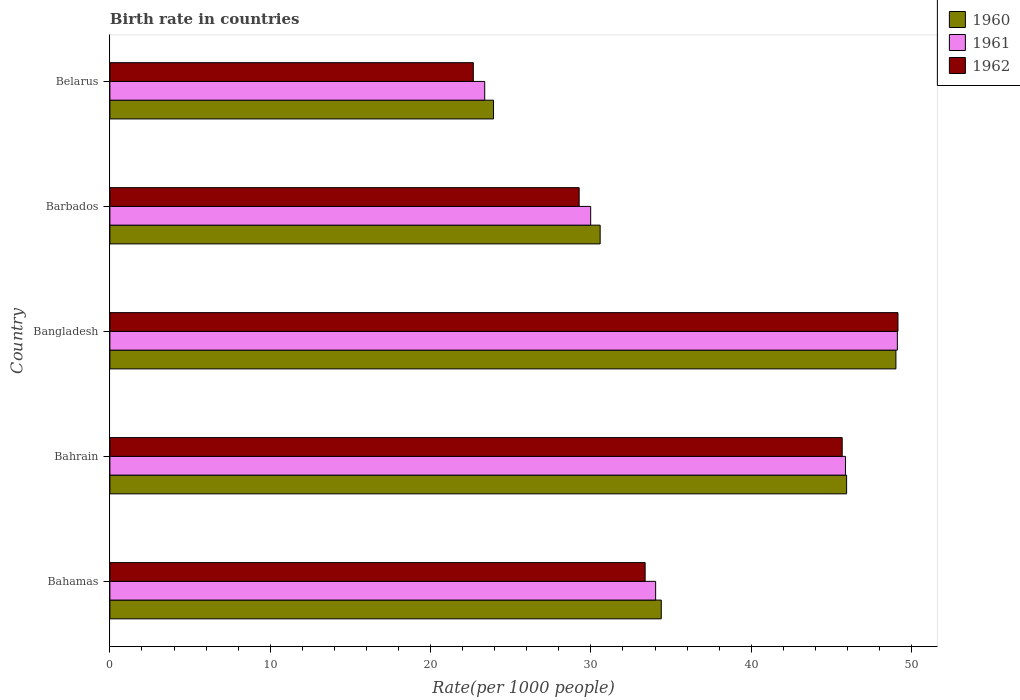How many bars are there on the 3rd tick from the top?
Your response must be concise. 3. How many bars are there on the 2nd tick from the bottom?
Give a very brief answer. 3. What is the label of the 1st group of bars from the top?
Your response must be concise. Belarus. In how many cases, is the number of bars for a given country not equal to the number of legend labels?
Keep it short and to the point. 0. What is the birth rate in 1961 in Barbados?
Give a very brief answer. 29.98. Across all countries, what is the maximum birth rate in 1962?
Your answer should be very brief. 49.15. Across all countries, what is the minimum birth rate in 1960?
Offer a very short reply. 23.93. In which country was the birth rate in 1962 minimum?
Offer a very short reply. Belarus. What is the total birth rate in 1961 in the graph?
Your answer should be very brief. 182.38. What is the difference between the birth rate in 1962 in Bangladesh and that in Belarus?
Your answer should be very brief. 26.48. What is the difference between the birth rate in 1960 in Barbados and the birth rate in 1961 in Belarus?
Ensure brevity in your answer.  7.2. What is the average birth rate in 1960 per country?
Ensure brevity in your answer.  36.77. What is the difference between the birth rate in 1961 and birth rate in 1962 in Belarus?
Provide a succinct answer. 0.71. What is the ratio of the birth rate in 1960 in Bahamas to that in Bangladesh?
Offer a terse response. 0.7. What is the difference between the highest and the second highest birth rate in 1962?
Provide a short and direct response. 3.48. What is the difference between the highest and the lowest birth rate in 1962?
Your answer should be very brief. 26.48. In how many countries, is the birth rate in 1960 greater than the average birth rate in 1960 taken over all countries?
Provide a short and direct response. 2. Is the sum of the birth rate in 1961 in Bangladesh and Belarus greater than the maximum birth rate in 1962 across all countries?
Keep it short and to the point. Yes. What does the 1st bar from the bottom in Bahamas represents?
Give a very brief answer. 1960. Is it the case that in every country, the sum of the birth rate in 1960 and birth rate in 1961 is greater than the birth rate in 1962?
Keep it short and to the point. Yes. How many countries are there in the graph?
Make the answer very short. 5. Are the values on the major ticks of X-axis written in scientific E-notation?
Ensure brevity in your answer.  No. How many legend labels are there?
Offer a terse response. 3. What is the title of the graph?
Your response must be concise. Birth rate in countries. Does "2015" appear as one of the legend labels in the graph?
Your answer should be compact. No. What is the label or title of the X-axis?
Give a very brief answer. Rate(per 1000 people). What is the label or title of the Y-axis?
Offer a terse response. Country. What is the Rate(per 1000 people) of 1960 in Bahamas?
Make the answer very short. 34.39. What is the Rate(per 1000 people) in 1961 in Bahamas?
Your response must be concise. 34.04. What is the Rate(per 1000 people) in 1962 in Bahamas?
Offer a very short reply. 33.38. What is the Rate(per 1000 people) in 1960 in Bahrain?
Offer a very short reply. 45.95. What is the Rate(per 1000 people) of 1961 in Bahrain?
Make the answer very short. 45.88. What is the Rate(per 1000 people) of 1962 in Bahrain?
Your answer should be compact. 45.67. What is the Rate(per 1000 people) in 1960 in Bangladesh?
Offer a very short reply. 49.02. What is the Rate(per 1000 people) of 1961 in Bangladesh?
Ensure brevity in your answer.  49.11. What is the Rate(per 1000 people) of 1962 in Bangladesh?
Your answer should be very brief. 49.15. What is the Rate(per 1000 people) in 1960 in Barbados?
Ensure brevity in your answer.  30.58. What is the Rate(per 1000 people) in 1961 in Barbados?
Provide a succinct answer. 29.98. What is the Rate(per 1000 people) in 1962 in Barbados?
Provide a short and direct response. 29.27. What is the Rate(per 1000 people) of 1960 in Belarus?
Ensure brevity in your answer.  23.93. What is the Rate(per 1000 people) of 1961 in Belarus?
Keep it short and to the point. 23.38. What is the Rate(per 1000 people) in 1962 in Belarus?
Provide a short and direct response. 22.66. Across all countries, what is the maximum Rate(per 1000 people) in 1960?
Make the answer very short. 49.02. Across all countries, what is the maximum Rate(per 1000 people) of 1961?
Provide a succinct answer. 49.11. Across all countries, what is the maximum Rate(per 1000 people) of 1962?
Ensure brevity in your answer.  49.15. Across all countries, what is the minimum Rate(per 1000 people) in 1960?
Provide a succinct answer. 23.93. Across all countries, what is the minimum Rate(per 1000 people) in 1961?
Give a very brief answer. 23.38. Across all countries, what is the minimum Rate(per 1000 people) in 1962?
Your response must be concise. 22.66. What is the total Rate(per 1000 people) of 1960 in the graph?
Your answer should be compact. 183.86. What is the total Rate(per 1000 people) in 1961 in the graph?
Your answer should be very brief. 182.38. What is the total Rate(per 1000 people) of 1962 in the graph?
Make the answer very short. 180.13. What is the difference between the Rate(per 1000 people) in 1960 in Bahamas and that in Bahrain?
Provide a succinct answer. -11.56. What is the difference between the Rate(per 1000 people) of 1961 in Bahamas and that in Bahrain?
Ensure brevity in your answer.  -11.84. What is the difference between the Rate(per 1000 people) of 1962 in Bahamas and that in Bahrain?
Your answer should be very brief. -12.29. What is the difference between the Rate(per 1000 people) of 1960 in Bahamas and that in Bangladesh?
Your answer should be very brief. -14.63. What is the difference between the Rate(per 1000 people) of 1961 in Bahamas and that in Bangladesh?
Keep it short and to the point. -15.07. What is the difference between the Rate(per 1000 people) in 1962 in Bahamas and that in Bangladesh?
Ensure brevity in your answer.  -15.77. What is the difference between the Rate(per 1000 people) of 1960 in Bahamas and that in Barbados?
Ensure brevity in your answer.  3.81. What is the difference between the Rate(per 1000 people) in 1961 in Bahamas and that in Barbados?
Ensure brevity in your answer.  4.05. What is the difference between the Rate(per 1000 people) of 1962 in Bahamas and that in Barbados?
Give a very brief answer. 4.12. What is the difference between the Rate(per 1000 people) in 1960 in Bahamas and that in Belarus?
Keep it short and to the point. 10.46. What is the difference between the Rate(per 1000 people) of 1961 in Bahamas and that in Belarus?
Make the answer very short. 10.66. What is the difference between the Rate(per 1000 people) in 1962 in Bahamas and that in Belarus?
Your response must be concise. 10.72. What is the difference between the Rate(per 1000 people) of 1960 in Bahrain and that in Bangladesh?
Your answer should be very brief. -3.08. What is the difference between the Rate(per 1000 people) of 1961 in Bahrain and that in Bangladesh?
Your response must be concise. -3.23. What is the difference between the Rate(per 1000 people) in 1962 in Bahrain and that in Bangladesh?
Keep it short and to the point. -3.48. What is the difference between the Rate(per 1000 people) in 1960 in Bahrain and that in Barbados?
Offer a terse response. 15.37. What is the difference between the Rate(per 1000 people) in 1961 in Bahrain and that in Barbados?
Provide a succinct answer. 15.89. What is the difference between the Rate(per 1000 people) of 1962 in Bahrain and that in Barbados?
Make the answer very short. 16.4. What is the difference between the Rate(per 1000 people) of 1960 in Bahrain and that in Belarus?
Keep it short and to the point. 22.02. What is the difference between the Rate(per 1000 people) in 1961 in Bahrain and that in Belarus?
Offer a very short reply. 22.5. What is the difference between the Rate(per 1000 people) of 1962 in Bahrain and that in Belarus?
Your answer should be very brief. 23. What is the difference between the Rate(per 1000 people) of 1960 in Bangladesh and that in Barbados?
Provide a succinct answer. 18.45. What is the difference between the Rate(per 1000 people) in 1961 in Bangladesh and that in Barbados?
Provide a succinct answer. 19.13. What is the difference between the Rate(per 1000 people) in 1962 in Bangladesh and that in Barbados?
Offer a terse response. 19.88. What is the difference between the Rate(per 1000 people) of 1960 in Bangladesh and that in Belarus?
Make the answer very short. 25.1. What is the difference between the Rate(per 1000 people) in 1961 in Bangladesh and that in Belarus?
Offer a very short reply. 25.73. What is the difference between the Rate(per 1000 people) in 1962 in Bangladesh and that in Belarus?
Provide a short and direct response. 26.48. What is the difference between the Rate(per 1000 people) in 1960 in Barbados and that in Belarus?
Your response must be concise. 6.65. What is the difference between the Rate(per 1000 people) in 1961 in Barbados and that in Belarus?
Offer a terse response. 6.61. What is the difference between the Rate(per 1000 people) in 1962 in Barbados and that in Belarus?
Make the answer very short. 6.6. What is the difference between the Rate(per 1000 people) of 1960 in Bahamas and the Rate(per 1000 people) of 1961 in Bahrain?
Ensure brevity in your answer.  -11.49. What is the difference between the Rate(per 1000 people) in 1960 in Bahamas and the Rate(per 1000 people) in 1962 in Bahrain?
Make the answer very short. -11.28. What is the difference between the Rate(per 1000 people) of 1961 in Bahamas and the Rate(per 1000 people) of 1962 in Bahrain?
Offer a terse response. -11.63. What is the difference between the Rate(per 1000 people) in 1960 in Bahamas and the Rate(per 1000 people) in 1961 in Bangladesh?
Your response must be concise. -14.72. What is the difference between the Rate(per 1000 people) in 1960 in Bahamas and the Rate(per 1000 people) in 1962 in Bangladesh?
Your answer should be compact. -14.76. What is the difference between the Rate(per 1000 people) of 1961 in Bahamas and the Rate(per 1000 people) of 1962 in Bangladesh?
Offer a very short reply. -15.11. What is the difference between the Rate(per 1000 people) of 1960 in Bahamas and the Rate(per 1000 people) of 1961 in Barbados?
Offer a terse response. 4.4. What is the difference between the Rate(per 1000 people) of 1960 in Bahamas and the Rate(per 1000 people) of 1962 in Barbados?
Your answer should be very brief. 5.12. What is the difference between the Rate(per 1000 people) of 1961 in Bahamas and the Rate(per 1000 people) of 1962 in Barbados?
Your answer should be very brief. 4.77. What is the difference between the Rate(per 1000 people) in 1960 in Bahamas and the Rate(per 1000 people) in 1961 in Belarus?
Keep it short and to the point. 11.01. What is the difference between the Rate(per 1000 people) in 1960 in Bahamas and the Rate(per 1000 people) in 1962 in Belarus?
Keep it short and to the point. 11.72. What is the difference between the Rate(per 1000 people) of 1961 in Bahamas and the Rate(per 1000 people) of 1962 in Belarus?
Offer a terse response. 11.37. What is the difference between the Rate(per 1000 people) of 1960 in Bahrain and the Rate(per 1000 people) of 1961 in Bangladesh?
Offer a very short reply. -3.17. What is the difference between the Rate(per 1000 people) of 1960 in Bahrain and the Rate(per 1000 people) of 1962 in Bangladesh?
Offer a terse response. -3.2. What is the difference between the Rate(per 1000 people) in 1961 in Bahrain and the Rate(per 1000 people) in 1962 in Bangladesh?
Keep it short and to the point. -3.27. What is the difference between the Rate(per 1000 people) in 1960 in Bahrain and the Rate(per 1000 people) in 1961 in Barbados?
Offer a terse response. 15.96. What is the difference between the Rate(per 1000 people) in 1960 in Bahrain and the Rate(per 1000 people) in 1962 in Barbados?
Make the answer very short. 16.68. What is the difference between the Rate(per 1000 people) in 1961 in Bahrain and the Rate(per 1000 people) in 1962 in Barbados?
Your answer should be very brief. 16.61. What is the difference between the Rate(per 1000 people) in 1960 in Bahrain and the Rate(per 1000 people) in 1961 in Belarus?
Make the answer very short. 22.57. What is the difference between the Rate(per 1000 people) in 1960 in Bahrain and the Rate(per 1000 people) in 1962 in Belarus?
Your answer should be compact. 23.28. What is the difference between the Rate(per 1000 people) of 1961 in Bahrain and the Rate(per 1000 people) of 1962 in Belarus?
Provide a succinct answer. 23.21. What is the difference between the Rate(per 1000 people) of 1960 in Bangladesh and the Rate(per 1000 people) of 1961 in Barbados?
Your answer should be compact. 19.04. What is the difference between the Rate(per 1000 people) in 1960 in Bangladesh and the Rate(per 1000 people) in 1962 in Barbados?
Offer a terse response. 19.76. What is the difference between the Rate(per 1000 people) of 1961 in Bangladesh and the Rate(per 1000 people) of 1962 in Barbados?
Your answer should be very brief. 19.84. What is the difference between the Rate(per 1000 people) of 1960 in Bangladesh and the Rate(per 1000 people) of 1961 in Belarus?
Keep it short and to the point. 25.64. What is the difference between the Rate(per 1000 people) in 1960 in Bangladesh and the Rate(per 1000 people) in 1962 in Belarus?
Offer a very short reply. 26.36. What is the difference between the Rate(per 1000 people) in 1961 in Bangladesh and the Rate(per 1000 people) in 1962 in Belarus?
Your answer should be compact. 26.45. What is the difference between the Rate(per 1000 people) of 1960 in Barbados and the Rate(per 1000 people) of 1961 in Belarus?
Your answer should be compact. 7.2. What is the difference between the Rate(per 1000 people) of 1960 in Barbados and the Rate(per 1000 people) of 1962 in Belarus?
Your response must be concise. 7.91. What is the difference between the Rate(per 1000 people) in 1961 in Barbados and the Rate(per 1000 people) in 1962 in Belarus?
Offer a terse response. 7.32. What is the average Rate(per 1000 people) in 1960 per country?
Ensure brevity in your answer.  36.77. What is the average Rate(per 1000 people) in 1961 per country?
Keep it short and to the point. 36.48. What is the average Rate(per 1000 people) of 1962 per country?
Provide a succinct answer. 36.03. What is the difference between the Rate(per 1000 people) of 1960 and Rate(per 1000 people) of 1961 in Bahamas?
Offer a very short reply. 0.35. What is the difference between the Rate(per 1000 people) of 1961 and Rate(per 1000 people) of 1962 in Bahamas?
Offer a terse response. 0.66. What is the difference between the Rate(per 1000 people) in 1960 and Rate(per 1000 people) in 1961 in Bahrain?
Offer a very short reply. 0.07. What is the difference between the Rate(per 1000 people) in 1960 and Rate(per 1000 people) in 1962 in Bahrain?
Your answer should be very brief. 0.28. What is the difference between the Rate(per 1000 people) of 1961 and Rate(per 1000 people) of 1962 in Bahrain?
Offer a very short reply. 0.21. What is the difference between the Rate(per 1000 people) of 1960 and Rate(per 1000 people) of 1961 in Bangladesh?
Offer a terse response. -0.09. What is the difference between the Rate(per 1000 people) in 1960 and Rate(per 1000 people) in 1962 in Bangladesh?
Make the answer very short. -0.13. What is the difference between the Rate(per 1000 people) in 1961 and Rate(per 1000 people) in 1962 in Bangladesh?
Your response must be concise. -0.04. What is the difference between the Rate(per 1000 people) of 1960 and Rate(per 1000 people) of 1961 in Barbados?
Give a very brief answer. 0.59. What is the difference between the Rate(per 1000 people) in 1960 and Rate(per 1000 people) in 1962 in Barbados?
Your answer should be compact. 1.31. What is the difference between the Rate(per 1000 people) in 1961 and Rate(per 1000 people) in 1962 in Barbados?
Give a very brief answer. 0.72. What is the difference between the Rate(per 1000 people) in 1960 and Rate(per 1000 people) in 1961 in Belarus?
Keep it short and to the point. 0.55. What is the difference between the Rate(per 1000 people) of 1960 and Rate(per 1000 people) of 1962 in Belarus?
Your response must be concise. 1.26. What is the difference between the Rate(per 1000 people) of 1961 and Rate(per 1000 people) of 1962 in Belarus?
Offer a terse response. 0.71. What is the ratio of the Rate(per 1000 people) of 1960 in Bahamas to that in Bahrain?
Give a very brief answer. 0.75. What is the ratio of the Rate(per 1000 people) of 1961 in Bahamas to that in Bahrain?
Offer a terse response. 0.74. What is the ratio of the Rate(per 1000 people) of 1962 in Bahamas to that in Bahrain?
Offer a terse response. 0.73. What is the ratio of the Rate(per 1000 people) of 1960 in Bahamas to that in Bangladesh?
Ensure brevity in your answer.  0.7. What is the ratio of the Rate(per 1000 people) of 1961 in Bahamas to that in Bangladesh?
Give a very brief answer. 0.69. What is the ratio of the Rate(per 1000 people) in 1962 in Bahamas to that in Bangladesh?
Ensure brevity in your answer.  0.68. What is the ratio of the Rate(per 1000 people) in 1960 in Bahamas to that in Barbados?
Your response must be concise. 1.12. What is the ratio of the Rate(per 1000 people) of 1961 in Bahamas to that in Barbados?
Your answer should be compact. 1.14. What is the ratio of the Rate(per 1000 people) in 1962 in Bahamas to that in Barbados?
Offer a terse response. 1.14. What is the ratio of the Rate(per 1000 people) in 1960 in Bahamas to that in Belarus?
Give a very brief answer. 1.44. What is the ratio of the Rate(per 1000 people) of 1961 in Bahamas to that in Belarus?
Give a very brief answer. 1.46. What is the ratio of the Rate(per 1000 people) of 1962 in Bahamas to that in Belarus?
Keep it short and to the point. 1.47. What is the ratio of the Rate(per 1000 people) of 1960 in Bahrain to that in Bangladesh?
Give a very brief answer. 0.94. What is the ratio of the Rate(per 1000 people) of 1961 in Bahrain to that in Bangladesh?
Provide a short and direct response. 0.93. What is the ratio of the Rate(per 1000 people) of 1962 in Bahrain to that in Bangladesh?
Provide a short and direct response. 0.93. What is the ratio of the Rate(per 1000 people) of 1960 in Bahrain to that in Barbados?
Your response must be concise. 1.5. What is the ratio of the Rate(per 1000 people) in 1961 in Bahrain to that in Barbados?
Make the answer very short. 1.53. What is the ratio of the Rate(per 1000 people) of 1962 in Bahrain to that in Barbados?
Keep it short and to the point. 1.56. What is the ratio of the Rate(per 1000 people) in 1960 in Bahrain to that in Belarus?
Your answer should be compact. 1.92. What is the ratio of the Rate(per 1000 people) in 1961 in Bahrain to that in Belarus?
Offer a very short reply. 1.96. What is the ratio of the Rate(per 1000 people) in 1962 in Bahrain to that in Belarus?
Give a very brief answer. 2.02. What is the ratio of the Rate(per 1000 people) in 1960 in Bangladesh to that in Barbados?
Provide a succinct answer. 1.6. What is the ratio of the Rate(per 1000 people) in 1961 in Bangladesh to that in Barbados?
Make the answer very short. 1.64. What is the ratio of the Rate(per 1000 people) of 1962 in Bangladesh to that in Barbados?
Provide a succinct answer. 1.68. What is the ratio of the Rate(per 1000 people) in 1960 in Bangladesh to that in Belarus?
Offer a very short reply. 2.05. What is the ratio of the Rate(per 1000 people) in 1961 in Bangladesh to that in Belarus?
Your answer should be very brief. 2.1. What is the ratio of the Rate(per 1000 people) in 1962 in Bangladesh to that in Belarus?
Offer a very short reply. 2.17. What is the ratio of the Rate(per 1000 people) of 1960 in Barbados to that in Belarus?
Your answer should be compact. 1.28. What is the ratio of the Rate(per 1000 people) of 1961 in Barbados to that in Belarus?
Your answer should be compact. 1.28. What is the ratio of the Rate(per 1000 people) in 1962 in Barbados to that in Belarus?
Ensure brevity in your answer.  1.29. What is the difference between the highest and the second highest Rate(per 1000 people) in 1960?
Your response must be concise. 3.08. What is the difference between the highest and the second highest Rate(per 1000 people) of 1961?
Offer a very short reply. 3.23. What is the difference between the highest and the second highest Rate(per 1000 people) in 1962?
Offer a very short reply. 3.48. What is the difference between the highest and the lowest Rate(per 1000 people) of 1960?
Your answer should be compact. 25.1. What is the difference between the highest and the lowest Rate(per 1000 people) in 1961?
Keep it short and to the point. 25.73. What is the difference between the highest and the lowest Rate(per 1000 people) of 1962?
Your response must be concise. 26.48. 